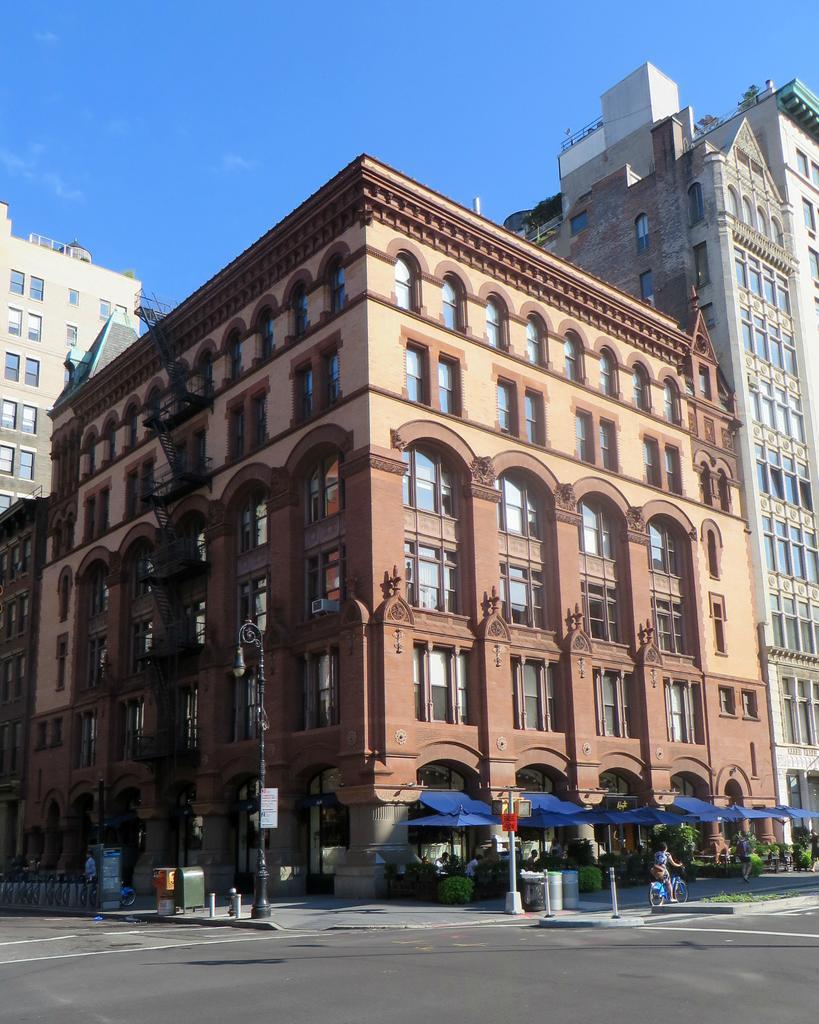In one or two sentences, can you explain what this image depicts? In this image there is a road, in the background there is a building, in front of the building there is a footpath, on footpath a person is riding a bicycle and a man is walking. 